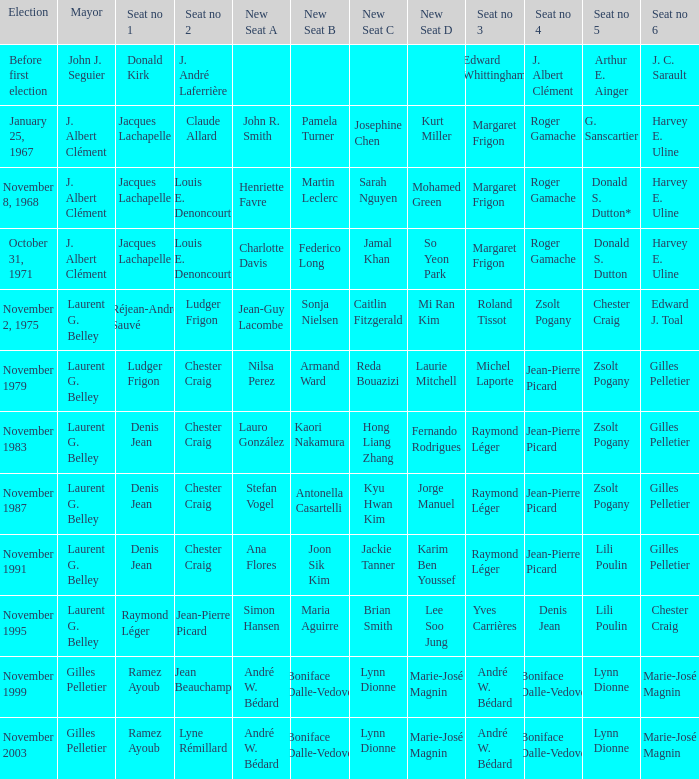Parse the full table. {'header': ['Election', 'Mayor', 'Seat no 1', 'Seat no 2', 'New Seat A', 'New Seat B', 'New Seat C', 'New Seat D', 'Seat no 3', 'Seat no 4', 'Seat no 5', 'Seat no 6'], 'rows': [['Before first election', 'John J. Seguier', 'Donald Kirk', 'J. André Laferrière', '', '', '', '', 'Edward Whittingham', 'J. Albert Clément', 'Arthur E. Ainger', 'J. C. Sarault'], ['January 25, 1967', 'J. Albert Clément', 'Jacques Lachapelle', 'Claude Allard', 'John R. Smith', 'Pamela Turner', 'Josephine Chen', 'Kurt Miller', 'Margaret Frigon', 'Roger Gamache', 'G. Sanscartier', 'Harvey E. Uline'], ['November 8, 1968', 'J. Albert Clément', 'Jacques Lachapelle', 'Louis E. Denoncourt', 'Henriette Favre', 'Martin Leclerc', 'Sarah Nguyen', 'Mohamed Green', 'Margaret Frigon', 'Roger Gamache', 'Donald S. Dutton*', 'Harvey E. Uline'], ['October 31, 1971', 'J. Albert Clément', 'Jacques Lachapelle', 'Louis E. Denoncourt', 'Charlotte Davis', 'Federico Long', 'Jamal Khan', 'So Yeon Park', 'Margaret Frigon', 'Roger Gamache', 'Donald S. Dutton', 'Harvey E. Uline'], ['November 2, 1975', 'Laurent G. Belley', 'Réjean-André Sauvé', 'Ludger Frigon', 'Jean-Guy Lacombe', 'Sonja Nielsen', 'Caitlin Fitzgerald', 'Mi Ran Kim', 'Roland Tissot', 'Zsolt Pogany', 'Chester Craig', 'Edward J. Toal'], ['November 1979', 'Laurent G. Belley', 'Ludger Frigon', 'Chester Craig', 'Nilsa Perez', 'Armand Ward', 'Reda Bouazizi', 'Laurie Mitchell', 'Michel Laporte', 'Jean-Pierre Picard', 'Zsolt Pogany', 'Gilles Pelletier'], ['November 1983', 'Laurent G. Belley', 'Denis Jean', 'Chester Craig', 'Lauro González', 'Kaori Nakamura', 'Hong Liang Zhang', 'Fernando Rodrigues', 'Raymond Léger', 'Jean-Pierre Picard', 'Zsolt Pogany', 'Gilles Pelletier'], ['November 1987', 'Laurent G. Belley', 'Denis Jean', 'Chester Craig', 'Stefan Vogel', 'Antonella Casartelli', 'Kyu Hwan Kim', 'Jorge Manuel', 'Raymond Léger', 'Jean-Pierre Picard', 'Zsolt Pogany', 'Gilles Pelletier'], ['November 1991', 'Laurent G. Belley', 'Denis Jean', 'Chester Craig', 'Ana Flores', 'Joon Sik Kim', 'Jackie Tanner', 'Karim Ben Youssef', 'Raymond Léger', 'Jean-Pierre Picard', 'Lili Poulin', 'Gilles Pelletier'], ['November 1995', 'Laurent G. Belley', 'Raymond Léger', 'Jean-Pierre Picard', 'Simon Hansen', 'Maria Aguirre', 'Brian Smith', 'Lee Soo Jung', 'Yves Carrières', 'Denis Jean', 'Lili Poulin', 'Chester Craig'], ['November 1999', 'Gilles Pelletier', 'Ramez Ayoub', 'Jean Beauchamp', 'André W. Bédard', 'Boniface Dalle-Vedove', 'Lynn Dionne', 'Marie-José Magnin', 'André W. Bédard', 'Boniface Dalle-Vedove', 'Lynn Dionne', 'Marie-José Magnin'], ['November 2003', 'Gilles Pelletier', 'Ramez Ayoub', 'Lyne Rémillard', 'André W. Bédard', 'Boniface Dalle-Vedove', 'Lynn Dionne', 'Marie-José Magnin', 'André W. Bédard', 'Boniface Dalle-Vedove', 'Lynn Dionne', 'Marie-José Magnin']]} Which election had seat no 1 filled by jacques lachapelle but seat no 5 was filled by g. sanscartier January 25, 1967. 